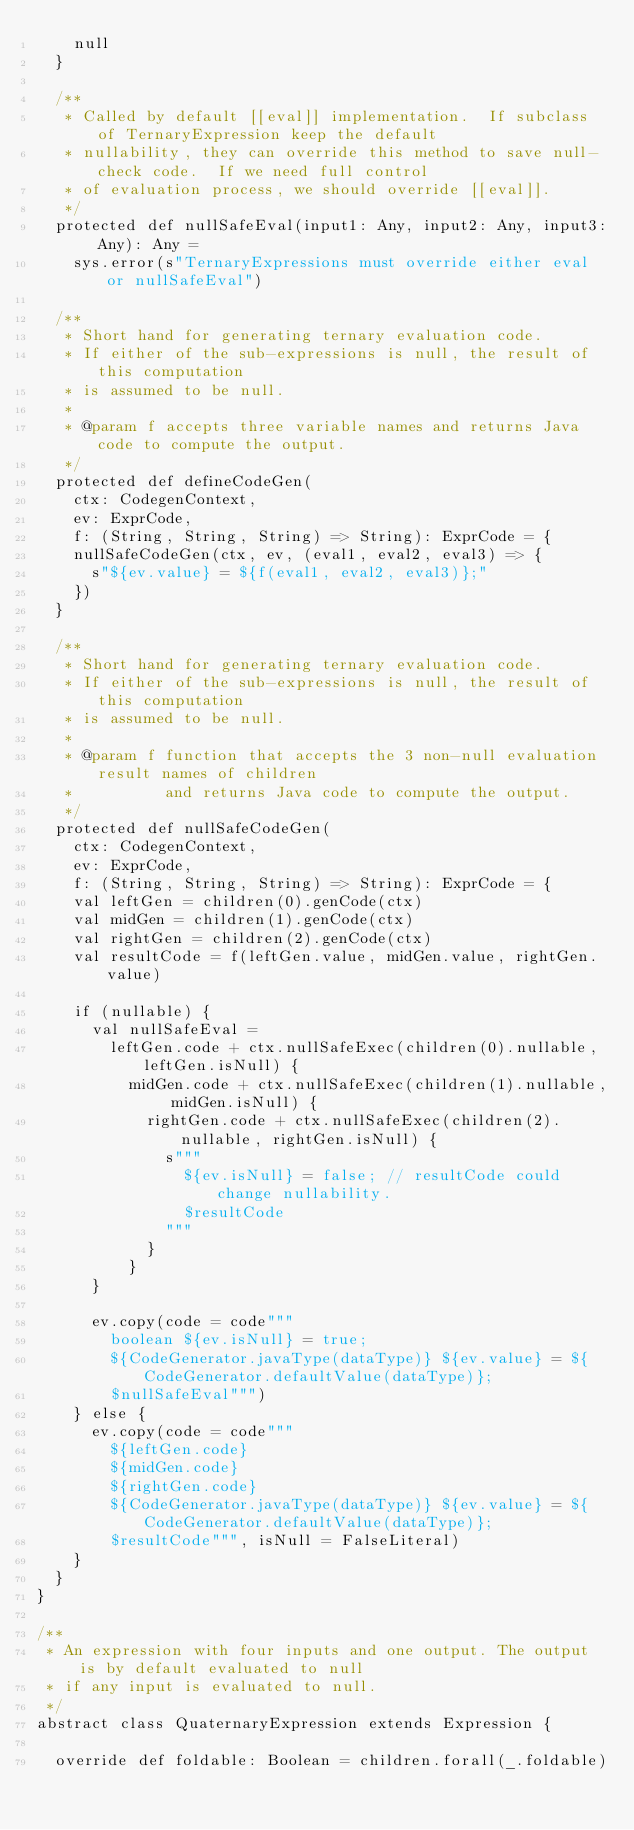<code> <loc_0><loc_0><loc_500><loc_500><_Scala_>    null
  }

  /**
   * Called by default [[eval]] implementation.  If subclass of TernaryExpression keep the default
   * nullability, they can override this method to save null-check code.  If we need full control
   * of evaluation process, we should override [[eval]].
   */
  protected def nullSafeEval(input1: Any, input2: Any, input3: Any): Any =
    sys.error(s"TernaryExpressions must override either eval or nullSafeEval")

  /**
   * Short hand for generating ternary evaluation code.
   * If either of the sub-expressions is null, the result of this computation
   * is assumed to be null.
   *
   * @param f accepts three variable names and returns Java code to compute the output.
   */
  protected def defineCodeGen(
    ctx: CodegenContext,
    ev: ExprCode,
    f: (String, String, String) => String): ExprCode = {
    nullSafeCodeGen(ctx, ev, (eval1, eval2, eval3) => {
      s"${ev.value} = ${f(eval1, eval2, eval3)};"
    })
  }

  /**
   * Short hand for generating ternary evaluation code.
   * If either of the sub-expressions is null, the result of this computation
   * is assumed to be null.
   *
   * @param f function that accepts the 3 non-null evaluation result names of children
   *          and returns Java code to compute the output.
   */
  protected def nullSafeCodeGen(
    ctx: CodegenContext,
    ev: ExprCode,
    f: (String, String, String) => String): ExprCode = {
    val leftGen = children(0).genCode(ctx)
    val midGen = children(1).genCode(ctx)
    val rightGen = children(2).genCode(ctx)
    val resultCode = f(leftGen.value, midGen.value, rightGen.value)

    if (nullable) {
      val nullSafeEval =
        leftGen.code + ctx.nullSafeExec(children(0).nullable, leftGen.isNull) {
          midGen.code + ctx.nullSafeExec(children(1).nullable, midGen.isNull) {
            rightGen.code + ctx.nullSafeExec(children(2).nullable, rightGen.isNull) {
              s"""
                ${ev.isNull} = false; // resultCode could change nullability.
                $resultCode
              """
            }
          }
      }

      ev.copy(code = code"""
        boolean ${ev.isNull} = true;
        ${CodeGenerator.javaType(dataType)} ${ev.value} = ${CodeGenerator.defaultValue(dataType)};
        $nullSafeEval""")
    } else {
      ev.copy(code = code"""
        ${leftGen.code}
        ${midGen.code}
        ${rightGen.code}
        ${CodeGenerator.javaType(dataType)} ${ev.value} = ${CodeGenerator.defaultValue(dataType)};
        $resultCode""", isNull = FalseLiteral)
    }
  }
}

/**
 * An expression with four inputs and one output. The output is by default evaluated to null
 * if any input is evaluated to null.
 */
abstract class QuaternaryExpression extends Expression {

  override def foldable: Boolean = children.forall(_.foldable)
</code> 